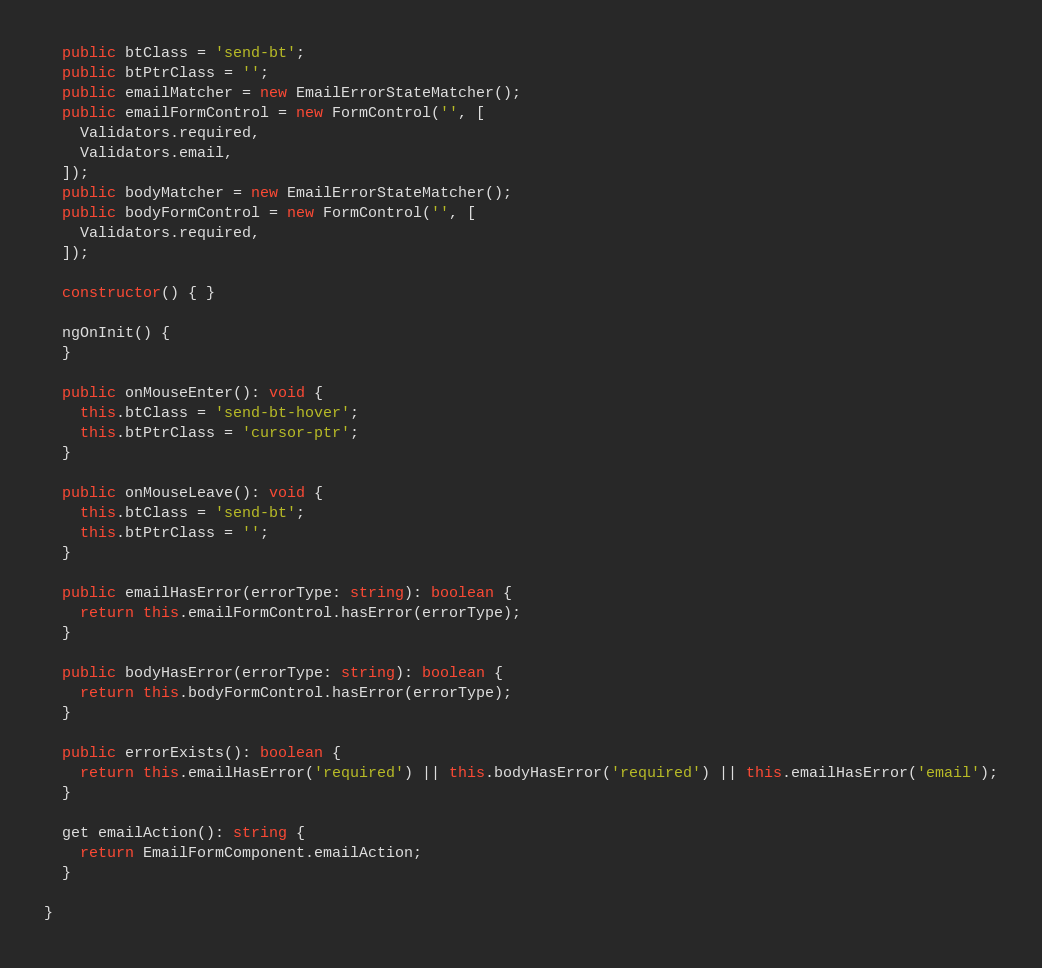Convert code to text. <code><loc_0><loc_0><loc_500><loc_500><_TypeScript_>
  public btClass = 'send-bt';
  public btPtrClass = '';
  public emailMatcher = new EmailErrorStateMatcher();
  public emailFormControl = new FormControl('', [
    Validators.required,
    Validators.email,
  ]);
  public bodyMatcher = new EmailErrorStateMatcher();
  public bodyFormControl = new FormControl('', [
    Validators.required,
  ]);

  constructor() { }

  ngOnInit() {
  }

  public onMouseEnter(): void {
    this.btClass = 'send-bt-hover';
    this.btPtrClass = 'cursor-ptr';
  }

  public onMouseLeave(): void {
    this.btClass = 'send-bt';
    this.btPtrClass = '';
  }

  public emailHasError(errorType: string): boolean {
    return this.emailFormControl.hasError(errorType);
  }

  public bodyHasError(errorType: string): boolean {
    return this.bodyFormControl.hasError(errorType);
  }

  public errorExists(): boolean {
    return this.emailHasError('required') || this.bodyHasError('required') || this.emailHasError('email');
  }

  get emailAction(): string {
    return EmailFormComponent.emailAction;
  }

}
</code> 